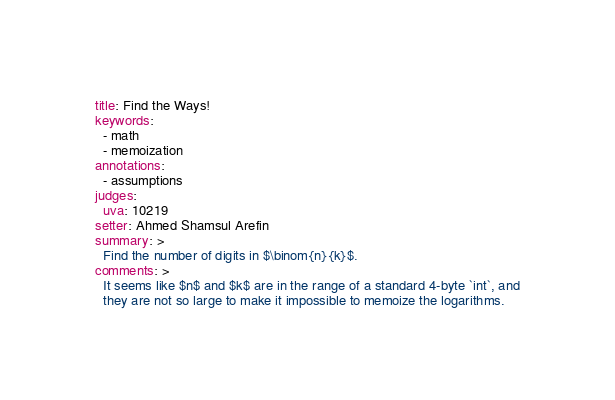Convert code to text. <code><loc_0><loc_0><loc_500><loc_500><_YAML_>title: Find the Ways!
keywords:
  - math
  - memoization
annotations:
  - assumptions
judges:
  uva: 10219
setter: Ahmed Shamsul Arefin
summary: >
  Find the number of digits in $\binom{n}{k}$.
comments: >
  It seems like $n$ and $k$ are in the range of a standard 4-byte `int`, and
  they are not so large to make it impossible to memoize the logarithms.
</code> 